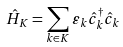Convert formula to latex. <formula><loc_0><loc_0><loc_500><loc_500>\hat { H } _ { K } = \sum _ { k \in K } \varepsilon _ { k } \hat { c } _ { k } ^ { \dagger } \hat { c } _ { k }</formula> 